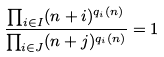Convert formula to latex. <formula><loc_0><loc_0><loc_500><loc_500>\frac { \prod _ { i \in I } ( n + i ) ^ { q _ { i } ( n ) } } { \prod _ { i \in J } ( n + j ) ^ { q _ { i } ( n ) } } = 1</formula> 